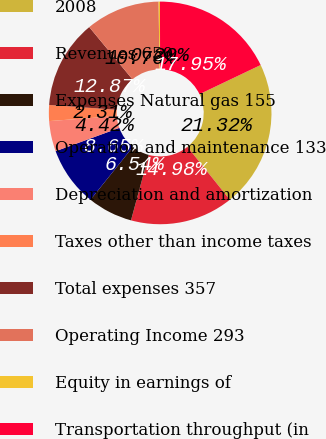<chart> <loc_0><loc_0><loc_500><loc_500><pie_chart><fcel>2008<fcel>Revenues 650<fcel>Expenses Natural gas 155<fcel>Operation and maintenance 133<fcel>Depreciation and amortization<fcel>Taxes other than income taxes<fcel>Total expenses 357<fcel>Operating Income 293<fcel>Equity in earnings of<fcel>Transportation throughput (in<nl><fcel>21.32%<fcel>14.98%<fcel>6.54%<fcel>8.65%<fcel>4.42%<fcel>2.31%<fcel>12.87%<fcel>10.76%<fcel>0.2%<fcel>17.95%<nl></chart> 